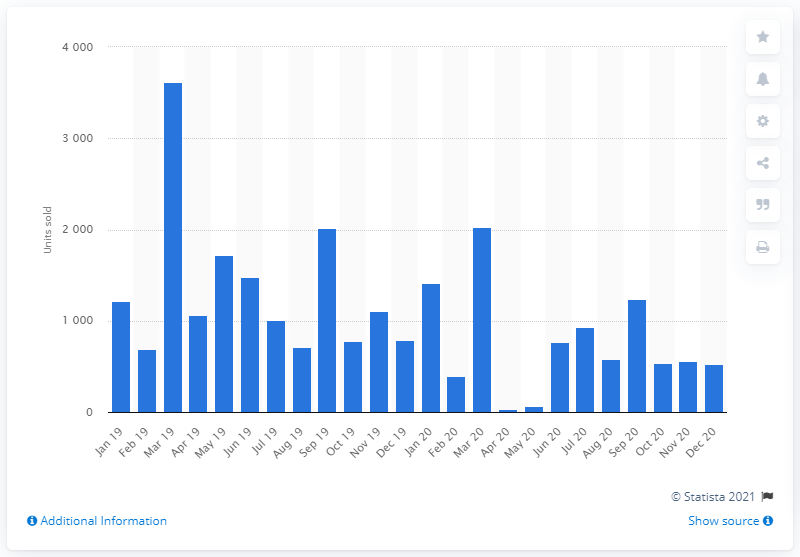Outline some significant characteristics in this image. In December 2020, a total of 531 Mitsubishi vehicles were purchased in the UK. 